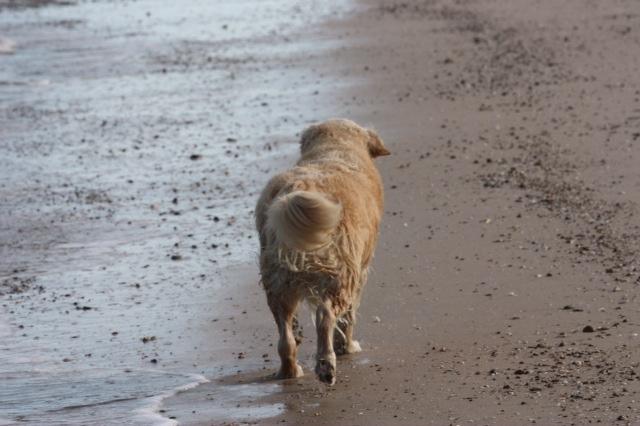Is the dog facing the camera?
Quick response, please. No. Where is the dog walking?
Short answer required. Beach. Is the dog planning to go swimming?
Keep it brief. Yes. 